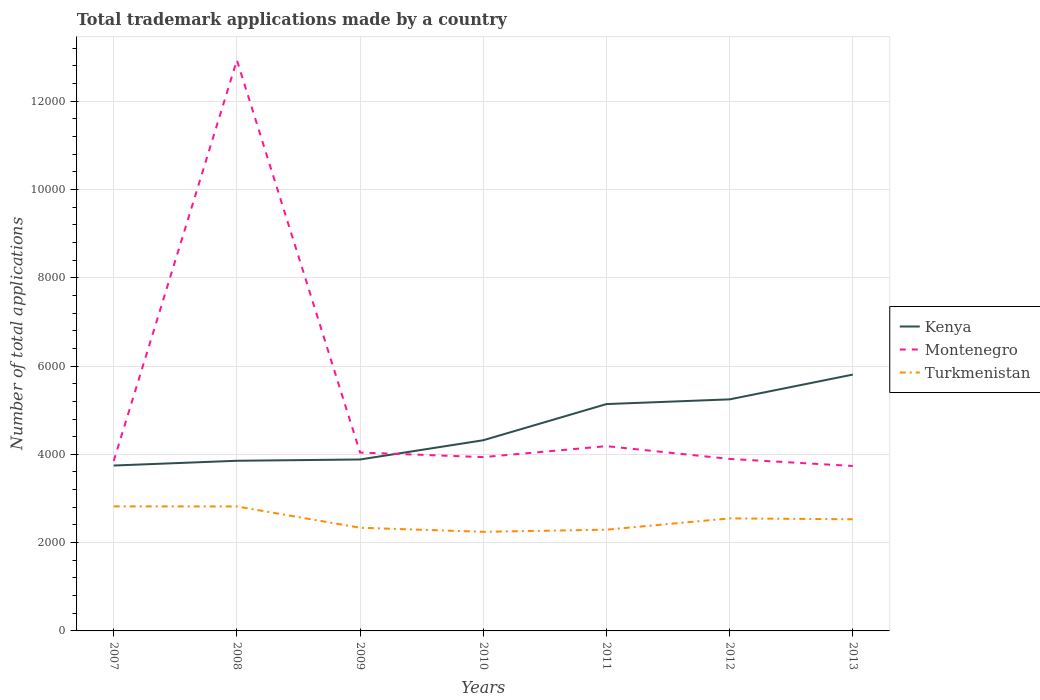How many different coloured lines are there?
Offer a very short reply. 3. Is the number of lines equal to the number of legend labels?
Your answer should be compact. Yes. Across all years, what is the maximum number of applications made by in Turkmenistan?
Your answer should be compact. 2245. What is the total number of applications made by in Montenegro in the graph?
Your answer should be very brief. 115. What is the difference between the highest and the second highest number of applications made by in Turkmenistan?
Your answer should be compact. 576. What is the difference between the highest and the lowest number of applications made by in Turkmenistan?
Your answer should be compact. 4. How many years are there in the graph?
Provide a short and direct response. 7. Are the values on the major ticks of Y-axis written in scientific E-notation?
Provide a short and direct response. No. Does the graph contain any zero values?
Give a very brief answer. No. Does the graph contain grids?
Offer a very short reply. Yes. Where does the legend appear in the graph?
Keep it short and to the point. Center right. How are the legend labels stacked?
Your response must be concise. Vertical. What is the title of the graph?
Your response must be concise. Total trademark applications made by a country. Does "Uzbekistan" appear as one of the legend labels in the graph?
Ensure brevity in your answer.  No. What is the label or title of the X-axis?
Your response must be concise. Years. What is the label or title of the Y-axis?
Your answer should be compact. Number of total applications. What is the Number of total applications of Kenya in 2007?
Ensure brevity in your answer.  3746. What is the Number of total applications of Montenegro in 2007?
Offer a very short reply. 3851. What is the Number of total applications in Turkmenistan in 2007?
Keep it short and to the point. 2821. What is the Number of total applications of Kenya in 2008?
Ensure brevity in your answer.  3854. What is the Number of total applications of Montenegro in 2008?
Offer a terse response. 1.29e+04. What is the Number of total applications in Turkmenistan in 2008?
Your answer should be very brief. 2819. What is the Number of total applications in Kenya in 2009?
Make the answer very short. 3883. What is the Number of total applications in Montenegro in 2009?
Provide a succinct answer. 4040. What is the Number of total applications of Turkmenistan in 2009?
Provide a short and direct response. 2337. What is the Number of total applications in Kenya in 2010?
Your answer should be compact. 4319. What is the Number of total applications of Montenegro in 2010?
Keep it short and to the point. 3937. What is the Number of total applications of Turkmenistan in 2010?
Offer a terse response. 2245. What is the Number of total applications in Kenya in 2011?
Offer a very short reply. 5138. What is the Number of total applications of Montenegro in 2011?
Keep it short and to the point. 4185. What is the Number of total applications of Turkmenistan in 2011?
Ensure brevity in your answer.  2293. What is the Number of total applications of Kenya in 2012?
Make the answer very short. 5245. What is the Number of total applications of Montenegro in 2012?
Offer a very short reply. 3896. What is the Number of total applications of Turkmenistan in 2012?
Your answer should be compact. 2549. What is the Number of total applications of Kenya in 2013?
Offer a terse response. 5806. What is the Number of total applications of Montenegro in 2013?
Keep it short and to the point. 3736. What is the Number of total applications in Turkmenistan in 2013?
Your response must be concise. 2529. Across all years, what is the maximum Number of total applications in Kenya?
Your answer should be compact. 5806. Across all years, what is the maximum Number of total applications in Montenegro?
Keep it short and to the point. 1.29e+04. Across all years, what is the maximum Number of total applications in Turkmenistan?
Keep it short and to the point. 2821. Across all years, what is the minimum Number of total applications in Kenya?
Give a very brief answer. 3746. Across all years, what is the minimum Number of total applications in Montenegro?
Ensure brevity in your answer.  3736. Across all years, what is the minimum Number of total applications in Turkmenistan?
Provide a short and direct response. 2245. What is the total Number of total applications of Kenya in the graph?
Offer a very short reply. 3.20e+04. What is the total Number of total applications of Montenegro in the graph?
Your answer should be very brief. 3.66e+04. What is the total Number of total applications in Turkmenistan in the graph?
Offer a very short reply. 1.76e+04. What is the difference between the Number of total applications of Kenya in 2007 and that in 2008?
Keep it short and to the point. -108. What is the difference between the Number of total applications of Montenegro in 2007 and that in 2008?
Give a very brief answer. -9077. What is the difference between the Number of total applications in Kenya in 2007 and that in 2009?
Keep it short and to the point. -137. What is the difference between the Number of total applications in Montenegro in 2007 and that in 2009?
Provide a succinct answer. -189. What is the difference between the Number of total applications of Turkmenistan in 2007 and that in 2009?
Offer a terse response. 484. What is the difference between the Number of total applications in Kenya in 2007 and that in 2010?
Make the answer very short. -573. What is the difference between the Number of total applications of Montenegro in 2007 and that in 2010?
Your answer should be very brief. -86. What is the difference between the Number of total applications of Turkmenistan in 2007 and that in 2010?
Offer a very short reply. 576. What is the difference between the Number of total applications in Kenya in 2007 and that in 2011?
Ensure brevity in your answer.  -1392. What is the difference between the Number of total applications in Montenegro in 2007 and that in 2011?
Provide a succinct answer. -334. What is the difference between the Number of total applications in Turkmenistan in 2007 and that in 2011?
Make the answer very short. 528. What is the difference between the Number of total applications of Kenya in 2007 and that in 2012?
Make the answer very short. -1499. What is the difference between the Number of total applications of Montenegro in 2007 and that in 2012?
Provide a short and direct response. -45. What is the difference between the Number of total applications of Turkmenistan in 2007 and that in 2012?
Make the answer very short. 272. What is the difference between the Number of total applications of Kenya in 2007 and that in 2013?
Ensure brevity in your answer.  -2060. What is the difference between the Number of total applications of Montenegro in 2007 and that in 2013?
Give a very brief answer. 115. What is the difference between the Number of total applications in Turkmenistan in 2007 and that in 2013?
Your response must be concise. 292. What is the difference between the Number of total applications in Montenegro in 2008 and that in 2009?
Offer a terse response. 8888. What is the difference between the Number of total applications of Turkmenistan in 2008 and that in 2009?
Offer a terse response. 482. What is the difference between the Number of total applications in Kenya in 2008 and that in 2010?
Your answer should be very brief. -465. What is the difference between the Number of total applications of Montenegro in 2008 and that in 2010?
Your answer should be compact. 8991. What is the difference between the Number of total applications of Turkmenistan in 2008 and that in 2010?
Give a very brief answer. 574. What is the difference between the Number of total applications in Kenya in 2008 and that in 2011?
Your answer should be very brief. -1284. What is the difference between the Number of total applications in Montenegro in 2008 and that in 2011?
Your response must be concise. 8743. What is the difference between the Number of total applications in Turkmenistan in 2008 and that in 2011?
Give a very brief answer. 526. What is the difference between the Number of total applications of Kenya in 2008 and that in 2012?
Provide a succinct answer. -1391. What is the difference between the Number of total applications in Montenegro in 2008 and that in 2012?
Give a very brief answer. 9032. What is the difference between the Number of total applications of Turkmenistan in 2008 and that in 2012?
Provide a short and direct response. 270. What is the difference between the Number of total applications of Kenya in 2008 and that in 2013?
Offer a terse response. -1952. What is the difference between the Number of total applications of Montenegro in 2008 and that in 2013?
Your answer should be very brief. 9192. What is the difference between the Number of total applications of Turkmenistan in 2008 and that in 2013?
Provide a short and direct response. 290. What is the difference between the Number of total applications of Kenya in 2009 and that in 2010?
Provide a succinct answer. -436. What is the difference between the Number of total applications in Montenegro in 2009 and that in 2010?
Give a very brief answer. 103. What is the difference between the Number of total applications of Turkmenistan in 2009 and that in 2010?
Provide a succinct answer. 92. What is the difference between the Number of total applications in Kenya in 2009 and that in 2011?
Provide a succinct answer. -1255. What is the difference between the Number of total applications of Montenegro in 2009 and that in 2011?
Provide a short and direct response. -145. What is the difference between the Number of total applications in Turkmenistan in 2009 and that in 2011?
Offer a very short reply. 44. What is the difference between the Number of total applications of Kenya in 2009 and that in 2012?
Your answer should be compact. -1362. What is the difference between the Number of total applications of Montenegro in 2009 and that in 2012?
Provide a succinct answer. 144. What is the difference between the Number of total applications of Turkmenistan in 2009 and that in 2012?
Give a very brief answer. -212. What is the difference between the Number of total applications in Kenya in 2009 and that in 2013?
Your answer should be compact. -1923. What is the difference between the Number of total applications of Montenegro in 2009 and that in 2013?
Provide a short and direct response. 304. What is the difference between the Number of total applications of Turkmenistan in 2009 and that in 2013?
Offer a very short reply. -192. What is the difference between the Number of total applications in Kenya in 2010 and that in 2011?
Provide a short and direct response. -819. What is the difference between the Number of total applications of Montenegro in 2010 and that in 2011?
Your answer should be compact. -248. What is the difference between the Number of total applications in Turkmenistan in 2010 and that in 2011?
Make the answer very short. -48. What is the difference between the Number of total applications in Kenya in 2010 and that in 2012?
Offer a very short reply. -926. What is the difference between the Number of total applications in Montenegro in 2010 and that in 2012?
Your answer should be very brief. 41. What is the difference between the Number of total applications in Turkmenistan in 2010 and that in 2012?
Keep it short and to the point. -304. What is the difference between the Number of total applications of Kenya in 2010 and that in 2013?
Keep it short and to the point. -1487. What is the difference between the Number of total applications in Montenegro in 2010 and that in 2013?
Your response must be concise. 201. What is the difference between the Number of total applications in Turkmenistan in 2010 and that in 2013?
Give a very brief answer. -284. What is the difference between the Number of total applications in Kenya in 2011 and that in 2012?
Keep it short and to the point. -107. What is the difference between the Number of total applications of Montenegro in 2011 and that in 2012?
Ensure brevity in your answer.  289. What is the difference between the Number of total applications in Turkmenistan in 2011 and that in 2012?
Your response must be concise. -256. What is the difference between the Number of total applications of Kenya in 2011 and that in 2013?
Make the answer very short. -668. What is the difference between the Number of total applications of Montenegro in 2011 and that in 2013?
Your answer should be very brief. 449. What is the difference between the Number of total applications in Turkmenistan in 2011 and that in 2013?
Your answer should be very brief. -236. What is the difference between the Number of total applications of Kenya in 2012 and that in 2013?
Your response must be concise. -561. What is the difference between the Number of total applications of Montenegro in 2012 and that in 2013?
Offer a very short reply. 160. What is the difference between the Number of total applications of Turkmenistan in 2012 and that in 2013?
Make the answer very short. 20. What is the difference between the Number of total applications of Kenya in 2007 and the Number of total applications of Montenegro in 2008?
Provide a short and direct response. -9182. What is the difference between the Number of total applications of Kenya in 2007 and the Number of total applications of Turkmenistan in 2008?
Provide a succinct answer. 927. What is the difference between the Number of total applications in Montenegro in 2007 and the Number of total applications in Turkmenistan in 2008?
Provide a short and direct response. 1032. What is the difference between the Number of total applications of Kenya in 2007 and the Number of total applications of Montenegro in 2009?
Your response must be concise. -294. What is the difference between the Number of total applications in Kenya in 2007 and the Number of total applications in Turkmenistan in 2009?
Keep it short and to the point. 1409. What is the difference between the Number of total applications of Montenegro in 2007 and the Number of total applications of Turkmenistan in 2009?
Ensure brevity in your answer.  1514. What is the difference between the Number of total applications in Kenya in 2007 and the Number of total applications in Montenegro in 2010?
Make the answer very short. -191. What is the difference between the Number of total applications of Kenya in 2007 and the Number of total applications of Turkmenistan in 2010?
Provide a succinct answer. 1501. What is the difference between the Number of total applications in Montenegro in 2007 and the Number of total applications in Turkmenistan in 2010?
Provide a short and direct response. 1606. What is the difference between the Number of total applications of Kenya in 2007 and the Number of total applications of Montenegro in 2011?
Make the answer very short. -439. What is the difference between the Number of total applications of Kenya in 2007 and the Number of total applications of Turkmenistan in 2011?
Your response must be concise. 1453. What is the difference between the Number of total applications of Montenegro in 2007 and the Number of total applications of Turkmenistan in 2011?
Give a very brief answer. 1558. What is the difference between the Number of total applications of Kenya in 2007 and the Number of total applications of Montenegro in 2012?
Offer a very short reply. -150. What is the difference between the Number of total applications in Kenya in 2007 and the Number of total applications in Turkmenistan in 2012?
Provide a succinct answer. 1197. What is the difference between the Number of total applications of Montenegro in 2007 and the Number of total applications of Turkmenistan in 2012?
Keep it short and to the point. 1302. What is the difference between the Number of total applications of Kenya in 2007 and the Number of total applications of Montenegro in 2013?
Your answer should be very brief. 10. What is the difference between the Number of total applications in Kenya in 2007 and the Number of total applications in Turkmenistan in 2013?
Ensure brevity in your answer.  1217. What is the difference between the Number of total applications in Montenegro in 2007 and the Number of total applications in Turkmenistan in 2013?
Give a very brief answer. 1322. What is the difference between the Number of total applications of Kenya in 2008 and the Number of total applications of Montenegro in 2009?
Offer a terse response. -186. What is the difference between the Number of total applications of Kenya in 2008 and the Number of total applications of Turkmenistan in 2009?
Your answer should be compact. 1517. What is the difference between the Number of total applications in Montenegro in 2008 and the Number of total applications in Turkmenistan in 2009?
Offer a terse response. 1.06e+04. What is the difference between the Number of total applications of Kenya in 2008 and the Number of total applications of Montenegro in 2010?
Give a very brief answer. -83. What is the difference between the Number of total applications of Kenya in 2008 and the Number of total applications of Turkmenistan in 2010?
Your answer should be very brief. 1609. What is the difference between the Number of total applications of Montenegro in 2008 and the Number of total applications of Turkmenistan in 2010?
Give a very brief answer. 1.07e+04. What is the difference between the Number of total applications in Kenya in 2008 and the Number of total applications in Montenegro in 2011?
Your response must be concise. -331. What is the difference between the Number of total applications of Kenya in 2008 and the Number of total applications of Turkmenistan in 2011?
Your answer should be very brief. 1561. What is the difference between the Number of total applications of Montenegro in 2008 and the Number of total applications of Turkmenistan in 2011?
Your answer should be compact. 1.06e+04. What is the difference between the Number of total applications in Kenya in 2008 and the Number of total applications in Montenegro in 2012?
Offer a very short reply. -42. What is the difference between the Number of total applications of Kenya in 2008 and the Number of total applications of Turkmenistan in 2012?
Give a very brief answer. 1305. What is the difference between the Number of total applications in Montenegro in 2008 and the Number of total applications in Turkmenistan in 2012?
Provide a short and direct response. 1.04e+04. What is the difference between the Number of total applications in Kenya in 2008 and the Number of total applications in Montenegro in 2013?
Your answer should be compact. 118. What is the difference between the Number of total applications of Kenya in 2008 and the Number of total applications of Turkmenistan in 2013?
Give a very brief answer. 1325. What is the difference between the Number of total applications of Montenegro in 2008 and the Number of total applications of Turkmenistan in 2013?
Your response must be concise. 1.04e+04. What is the difference between the Number of total applications in Kenya in 2009 and the Number of total applications in Montenegro in 2010?
Offer a very short reply. -54. What is the difference between the Number of total applications in Kenya in 2009 and the Number of total applications in Turkmenistan in 2010?
Make the answer very short. 1638. What is the difference between the Number of total applications in Montenegro in 2009 and the Number of total applications in Turkmenistan in 2010?
Provide a short and direct response. 1795. What is the difference between the Number of total applications in Kenya in 2009 and the Number of total applications in Montenegro in 2011?
Offer a terse response. -302. What is the difference between the Number of total applications in Kenya in 2009 and the Number of total applications in Turkmenistan in 2011?
Offer a terse response. 1590. What is the difference between the Number of total applications of Montenegro in 2009 and the Number of total applications of Turkmenistan in 2011?
Provide a short and direct response. 1747. What is the difference between the Number of total applications in Kenya in 2009 and the Number of total applications in Turkmenistan in 2012?
Your answer should be very brief. 1334. What is the difference between the Number of total applications in Montenegro in 2009 and the Number of total applications in Turkmenistan in 2012?
Your answer should be very brief. 1491. What is the difference between the Number of total applications of Kenya in 2009 and the Number of total applications of Montenegro in 2013?
Provide a short and direct response. 147. What is the difference between the Number of total applications in Kenya in 2009 and the Number of total applications in Turkmenistan in 2013?
Keep it short and to the point. 1354. What is the difference between the Number of total applications of Montenegro in 2009 and the Number of total applications of Turkmenistan in 2013?
Your answer should be very brief. 1511. What is the difference between the Number of total applications of Kenya in 2010 and the Number of total applications of Montenegro in 2011?
Give a very brief answer. 134. What is the difference between the Number of total applications of Kenya in 2010 and the Number of total applications of Turkmenistan in 2011?
Offer a terse response. 2026. What is the difference between the Number of total applications of Montenegro in 2010 and the Number of total applications of Turkmenistan in 2011?
Keep it short and to the point. 1644. What is the difference between the Number of total applications of Kenya in 2010 and the Number of total applications of Montenegro in 2012?
Your answer should be compact. 423. What is the difference between the Number of total applications of Kenya in 2010 and the Number of total applications of Turkmenistan in 2012?
Ensure brevity in your answer.  1770. What is the difference between the Number of total applications in Montenegro in 2010 and the Number of total applications in Turkmenistan in 2012?
Provide a succinct answer. 1388. What is the difference between the Number of total applications of Kenya in 2010 and the Number of total applications of Montenegro in 2013?
Keep it short and to the point. 583. What is the difference between the Number of total applications in Kenya in 2010 and the Number of total applications in Turkmenistan in 2013?
Your answer should be compact. 1790. What is the difference between the Number of total applications in Montenegro in 2010 and the Number of total applications in Turkmenistan in 2013?
Keep it short and to the point. 1408. What is the difference between the Number of total applications in Kenya in 2011 and the Number of total applications in Montenegro in 2012?
Provide a succinct answer. 1242. What is the difference between the Number of total applications in Kenya in 2011 and the Number of total applications in Turkmenistan in 2012?
Your answer should be very brief. 2589. What is the difference between the Number of total applications of Montenegro in 2011 and the Number of total applications of Turkmenistan in 2012?
Your response must be concise. 1636. What is the difference between the Number of total applications of Kenya in 2011 and the Number of total applications of Montenegro in 2013?
Your answer should be compact. 1402. What is the difference between the Number of total applications of Kenya in 2011 and the Number of total applications of Turkmenistan in 2013?
Your answer should be very brief. 2609. What is the difference between the Number of total applications of Montenegro in 2011 and the Number of total applications of Turkmenistan in 2013?
Make the answer very short. 1656. What is the difference between the Number of total applications of Kenya in 2012 and the Number of total applications of Montenegro in 2013?
Keep it short and to the point. 1509. What is the difference between the Number of total applications in Kenya in 2012 and the Number of total applications in Turkmenistan in 2013?
Provide a short and direct response. 2716. What is the difference between the Number of total applications of Montenegro in 2012 and the Number of total applications of Turkmenistan in 2013?
Provide a short and direct response. 1367. What is the average Number of total applications in Kenya per year?
Provide a succinct answer. 4570.14. What is the average Number of total applications of Montenegro per year?
Your answer should be compact. 5224.71. What is the average Number of total applications of Turkmenistan per year?
Make the answer very short. 2513.29. In the year 2007, what is the difference between the Number of total applications of Kenya and Number of total applications of Montenegro?
Provide a short and direct response. -105. In the year 2007, what is the difference between the Number of total applications in Kenya and Number of total applications in Turkmenistan?
Your response must be concise. 925. In the year 2007, what is the difference between the Number of total applications of Montenegro and Number of total applications of Turkmenistan?
Offer a very short reply. 1030. In the year 2008, what is the difference between the Number of total applications in Kenya and Number of total applications in Montenegro?
Your answer should be very brief. -9074. In the year 2008, what is the difference between the Number of total applications in Kenya and Number of total applications in Turkmenistan?
Provide a succinct answer. 1035. In the year 2008, what is the difference between the Number of total applications of Montenegro and Number of total applications of Turkmenistan?
Make the answer very short. 1.01e+04. In the year 2009, what is the difference between the Number of total applications in Kenya and Number of total applications in Montenegro?
Provide a short and direct response. -157. In the year 2009, what is the difference between the Number of total applications of Kenya and Number of total applications of Turkmenistan?
Ensure brevity in your answer.  1546. In the year 2009, what is the difference between the Number of total applications in Montenegro and Number of total applications in Turkmenistan?
Offer a very short reply. 1703. In the year 2010, what is the difference between the Number of total applications in Kenya and Number of total applications in Montenegro?
Your answer should be compact. 382. In the year 2010, what is the difference between the Number of total applications of Kenya and Number of total applications of Turkmenistan?
Your answer should be compact. 2074. In the year 2010, what is the difference between the Number of total applications of Montenegro and Number of total applications of Turkmenistan?
Offer a very short reply. 1692. In the year 2011, what is the difference between the Number of total applications in Kenya and Number of total applications in Montenegro?
Offer a very short reply. 953. In the year 2011, what is the difference between the Number of total applications of Kenya and Number of total applications of Turkmenistan?
Give a very brief answer. 2845. In the year 2011, what is the difference between the Number of total applications in Montenegro and Number of total applications in Turkmenistan?
Provide a short and direct response. 1892. In the year 2012, what is the difference between the Number of total applications in Kenya and Number of total applications in Montenegro?
Provide a succinct answer. 1349. In the year 2012, what is the difference between the Number of total applications in Kenya and Number of total applications in Turkmenistan?
Provide a succinct answer. 2696. In the year 2012, what is the difference between the Number of total applications of Montenegro and Number of total applications of Turkmenistan?
Your response must be concise. 1347. In the year 2013, what is the difference between the Number of total applications of Kenya and Number of total applications of Montenegro?
Provide a short and direct response. 2070. In the year 2013, what is the difference between the Number of total applications of Kenya and Number of total applications of Turkmenistan?
Offer a terse response. 3277. In the year 2013, what is the difference between the Number of total applications of Montenegro and Number of total applications of Turkmenistan?
Provide a short and direct response. 1207. What is the ratio of the Number of total applications in Kenya in 2007 to that in 2008?
Offer a very short reply. 0.97. What is the ratio of the Number of total applications of Montenegro in 2007 to that in 2008?
Provide a succinct answer. 0.3. What is the ratio of the Number of total applications of Kenya in 2007 to that in 2009?
Offer a very short reply. 0.96. What is the ratio of the Number of total applications in Montenegro in 2007 to that in 2009?
Offer a terse response. 0.95. What is the ratio of the Number of total applications of Turkmenistan in 2007 to that in 2009?
Give a very brief answer. 1.21. What is the ratio of the Number of total applications of Kenya in 2007 to that in 2010?
Your answer should be very brief. 0.87. What is the ratio of the Number of total applications of Montenegro in 2007 to that in 2010?
Keep it short and to the point. 0.98. What is the ratio of the Number of total applications in Turkmenistan in 2007 to that in 2010?
Your answer should be very brief. 1.26. What is the ratio of the Number of total applications in Kenya in 2007 to that in 2011?
Keep it short and to the point. 0.73. What is the ratio of the Number of total applications of Montenegro in 2007 to that in 2011?
Offer a very short reply. 0.92. What is the ratio of the Number of total applications in Turkmenistan in 2007 to that in 2011?
Make the answer very short. 1.23. What is the ratio of the Number of total applications of Kenya in 2007 to that in 2012?
Provide a short and direct response. 0.71. What is the ratio of the Number of total applications in Montenegro in 2007 to that in 2012?
Your answer should be very brief. 0.99. What is the ratio of the Number of total applications of Turkmenistan in 2007 to that in 2012?
Offer a terse response. 1.11. What is the ratio of the Number of total applications of Kenya in 2007 to that in 2013?
Your answer should be very brief. 0.65. What is the ratio of the Number of total applications of Montenegro in 2007 to that in 2013?
Ensure brevity in your answer.  1.03. What is the ratio of the Number of total applications in Turkmenistan in 2007 to that in 2013?
Give a very brief answer. 1.12. What is the ratio of the Number of total applications of Turkmenistan in 2008 to that in 2009?
Keep it short and to the point. 1.21. What is the ratio of the Number of total applications of Kenya in 2008 to that in 2010?
Provide a short and direct response. 0.89. What is the ratio of the Number of total applications in Montenegro in 2008 to that in 2010?
Make the answer very short. 3.28. What is the ratio of the Number of total applications in Turkmenistan in 2008 to that in 2010?
Your answer should be compact. 1.26. What is the ratio of the Number of total applications of Kenya in 2008 to that in 2011?
Provide a short and direct response. 0.75. What is the ratio of the Number of total applications in Montenegro in 2008 to that in 2011?
Offer a very short reply. 3.09. What is the ratio of the Number of total applications of Turkmenistan in 2008 to that in 2011?
Make the answer very short. 1.23. What is the ratio of the Number of total applications of Kenya in 2008 to that in 2012?
Your answer should be very brief. 0.73. What is the ratio of the Number of total applications of Montenegro in 2008 to that in 2012?
Offer a very short reply. 3.32. What is the ratio of the Number of total applications in Turkmenistan in 2008 to that in 2012?
Provide a succinct answer. 1.11. What is the ratio of the Number of total applications in Kenya in 2008 to that in 2013?
Your response must be concise. 0.66. What is the ratio of the Number of total applications in Montenegro in 2008 to that in 2013?
Provide a short and direct response. 3.46. What is the ratio of the Number of total applications in Turkmenistan in 2008 to that in 2013?
Offer a very short reply. 1.11. What is the ratio of the Number of total applications in Kenya in 2009 to that in 2010?
Make the answer very short. 0.9. What is the ratio of the Number of total applications in Montenegro in 2009 to that in 2010?
Provide a short and direct response. 1.03. What is the ratio of the Number of total applications in Turkmenistan in 2009 to that in 2010?
Keep it short and to the point. 1.04. What is the ratio of the Number of total applications of Kenya in 2009 to that in 2011?
Offer a terse response. 0.76. What is the ratio of the Number of total applications in Montenegro in 2009 to that in 2011?
Provide a succinct answer. 0.97. What is the ratio of the Number of total applications of Turkmenistan in 2009 to that in 2011?
Provide a short and direct response. 1.02. What is the ratio of the Number of total applications of Kenya in 2009 to that in 2012?
Offer a terse response. 0.74. What is the ratio of the Number of total applications in Turkmenistan in 2009 to that in 2012?
Provide a short and direct response. 0.92. What is the ratio of the Number of total applications of Kenya in 2009 to that in 2013?
Provide a succinct answer. 0.67. What is the ratio of the Number of total applications of Montenegro in 2009 to that in 2013?
Offer a terse response. 1.08. What is the ratio of the Number of total applications of Turkmenistan in 2009 to that in 2013?
Provide a short and direct response. 0.92. What is the ratio of the Number of total applications of Kenya in 2010 to that in 2011?
Ensure brevity in your answer.  0.84. What is the ratio of the Number of total applications of Montenegro in 2010 to that in 2011?
Give a very brief answer. 0.94. What is the ratio of the Number of total applications of Turkmenistan in 2010 to that in 2011?
Provide a short and direct response. 0.98. What is the ratio of the Number of total applications of Kenya in 2010 to that in 2012?
Your answer should be very brief. 0.82. What is the ratio of the Number of total applications in Montenegro in 2010 to that in 2012?
Offer a terse response. 1.01. What is the ratio of the Number of total applications of Turkmenistan in 2010 to that in 2012?
Offer a terse response. 0.88. What is the ratio of the Number of total applications in Kenya in 2010 to that in 2013?
Offer a terse response. 0.74. What is the ratio of the Number of total applications of Montenegro in 2010 to that in 2013?
Give a very brief answer. 1.05. What is the ratio of the Number of total applications of Turkmenistan in 2010 to that in 2013?
Your answer should be compact. 0.89. What is the ratio of the Number of total applications in Kenya in 2011 to that in 2012?
Make the answer very short. 0.98. What is the ratio of the Number of total applications in Montenegro in 2011 to that in 2012?
Ensure brevity in your answer.  1.07. What is the ratio of the Number of total applications in Turkmenistan in 2011 to that in 2012?
Your answer should be compact. 0.9. What is the ratio of the Number of total applications in Kenya in 2011 to that in 2013?
Make the answer very short. 0.88. What is the ratio of the Number of total applications of Montenegro in 2011 to that in 2013?
Your answer should be compact. 1.12. What is the ratio of the Number of total applications in Turkmenistan in 2011 to that in 2013?
Ensure brevity in your answer.  0.91. What is the ratio of the Number of total applications of Kenya in 2012 to that in 2013?
Provide a succinct answer. 0.9. What is the ratio of the Number of total applications of Montenegro in 2012 to that in 2013?
Provide a succinct answer. 1.04. What is the ratio of the Number of total applications in Turkmenistan in 2012 to that in 2013?
Your answer should be very brief. 1.01. What is the difference between the highest and the second highest Number of total applications of Kenya?
Your answer should be very brief. 561. What is the difference between the highest and the second highest Number of total applications of Montenegro?
Offer a terse response. 8743. What is the difference between the highest and the second highest Number of total applications of Turkmenistan?
Your answer should be very brief. 2. What is the difference between the highest and the lowest Number of total applications of Kenya?
Provide a succinct answer. 2060. What is the difference between the highest and the lowest Number of total applications of Montenegro?
Ensure brevity in your answer.  9192. What is the difference between the highest and the lowest Number of total applications in Turkmenistan?
Offer a very short reply. 576. 